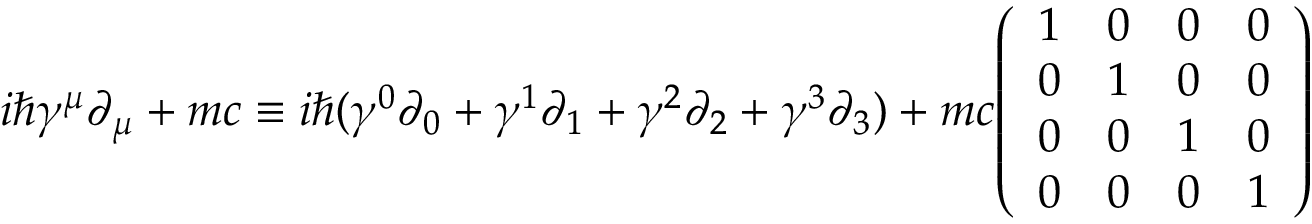Convert formula to latex. <formula><loc_0><loc_0><loc_500><loc_500>i \hbar { \gamma } ^ { \mu } \partial _ { \mu } + m c \equiv i \hbar { ( } \gamma ^ { 0 } \partial _ { 0 } + \gamma ^ { 1 } \partial _ { 1 } + \gamma ^ { 2 } \partial _ { 2 } + \gamma ^ { 3 } \partial _ { 3 } ) + m c { \left ( \begin{array} { l l l l } { 1 } & { 0 } & { 0 } & { 0 } \\ { 0 } & { 1 } & { 0 } & { 0 } \\ { 0 } & { 0 } & { 1 } & { 0 } \\ { 0 } & { 0 } & { 0 } & { 1 } \end{array} \right ) }</formula> 